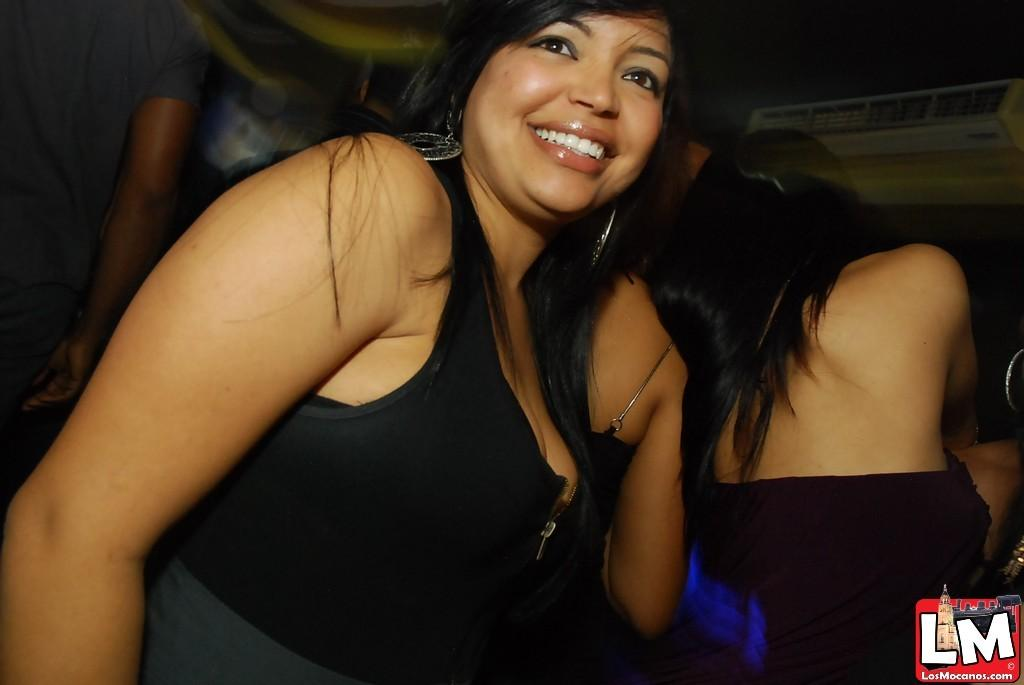<image>
Present a compact description of the photo's key features. A woman smiles for a picture with the watermark LM. 